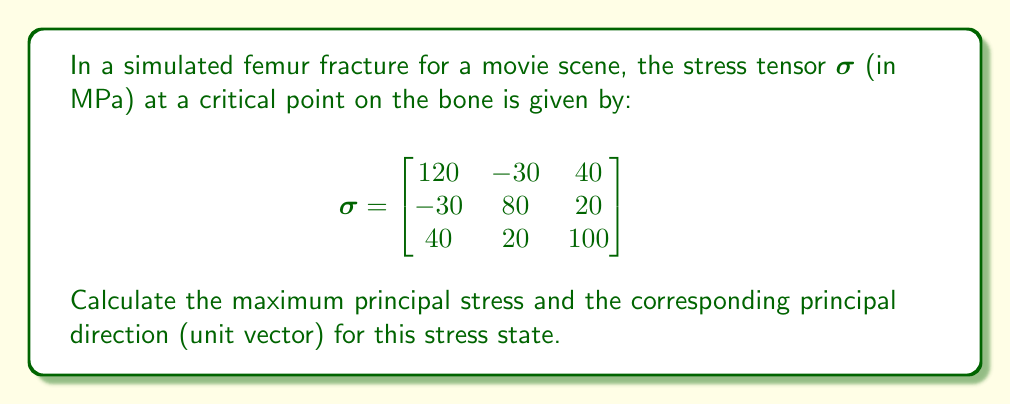Teach me how to tackle this problem. To find the maximum principal stress and its direction, we need to solve the eigenvalue problem for the stress tensor.

Step 1: Set up the characteristic equation
$\det(\sigma - \lambda I) = 0$, where $I$ is the 3x3 identity matrix.

Step 2: Expand the determinant
$$\begin{vmatrix}
120-\lambda & -30 & 40 \\
-30 & 80-\lambda & 20 \\
40 & 20 & 100-\lambda
\end{vmatrix} = 0$$

Step 3: Solve the resulting cubic equation
$-\lambda^3 + 300\lambda^2 - 28100\lambda + 816000 = 0$

Using a numerical method or computer algebra system, we find the roots:
$\lambda_1 \approx 164.4$ MPa
$\lambda_2 \approx 89.3$ MPa
$\lambda_3 \approx 46.3$ MPa

The maximum principal stress is $\lambda_1 \approx 164.4$ MPa.

Step 4: Find the eigenvector corresponding to $\lambda_1$
Solve $(\sigma - \lambda_1 I)\vec{v} = \vec{0}$

$$\begin{bmatrix}
-44.4 & -30 & 40 \\
-30 & -84.4 & 20 \\
40 & 20 & -64.4
\end{bmatrix}\begin{bmatrix}
v_1 \\ v_2 \\ v_3
\end{bmatrix} = \begin{bmatrix}
0 \\ 0 \\ 0
\end{bmatrix}$$

Solving this system (e.g., using Gaussian elimination) gives:
$\vec{v} \approx (0.7071, -0.3536, 0.6124)$

Step 5: Normalize the eigenvector to get the unit vector
$\vec{u} = \frac{\vec{v}}{|\vec{v}|} \approx (0.7071, -0.3536, 0.6124)$

This unit vector is already normalized, so it represents the principal direction.
Answer: Maximum principal stress: 164.4 MPa; Principal direction: (0.7071, -0.3536, 0.6124) 